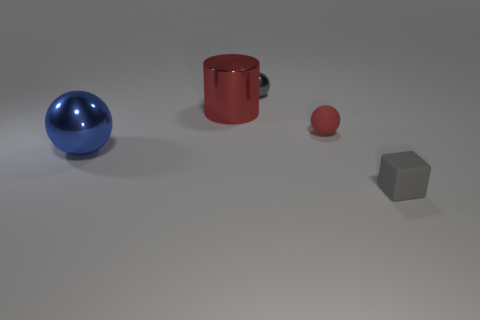Subtract all small red rubber spheres. How many spheres are left? 2 Add 4 large shiny balls. How many objects exist? 9 Subtract all blue balls. How many balls are left? 2 Subtract 1 balls. How many balls are left? 2 Subtract all blocks. How many objects are left? 4 Add 4 blue balls. How many blue balls are left? 5 Add 3 gray balls. How many gray balls exist? 4 Subtract 0 brown cylinders. How many objects are left? 5 Subtract all brown balls. Subtract all blue cylinders. How many balls are left? 3 Subtract all blue things. Subtract all green cubes. How many objects are left? 4 